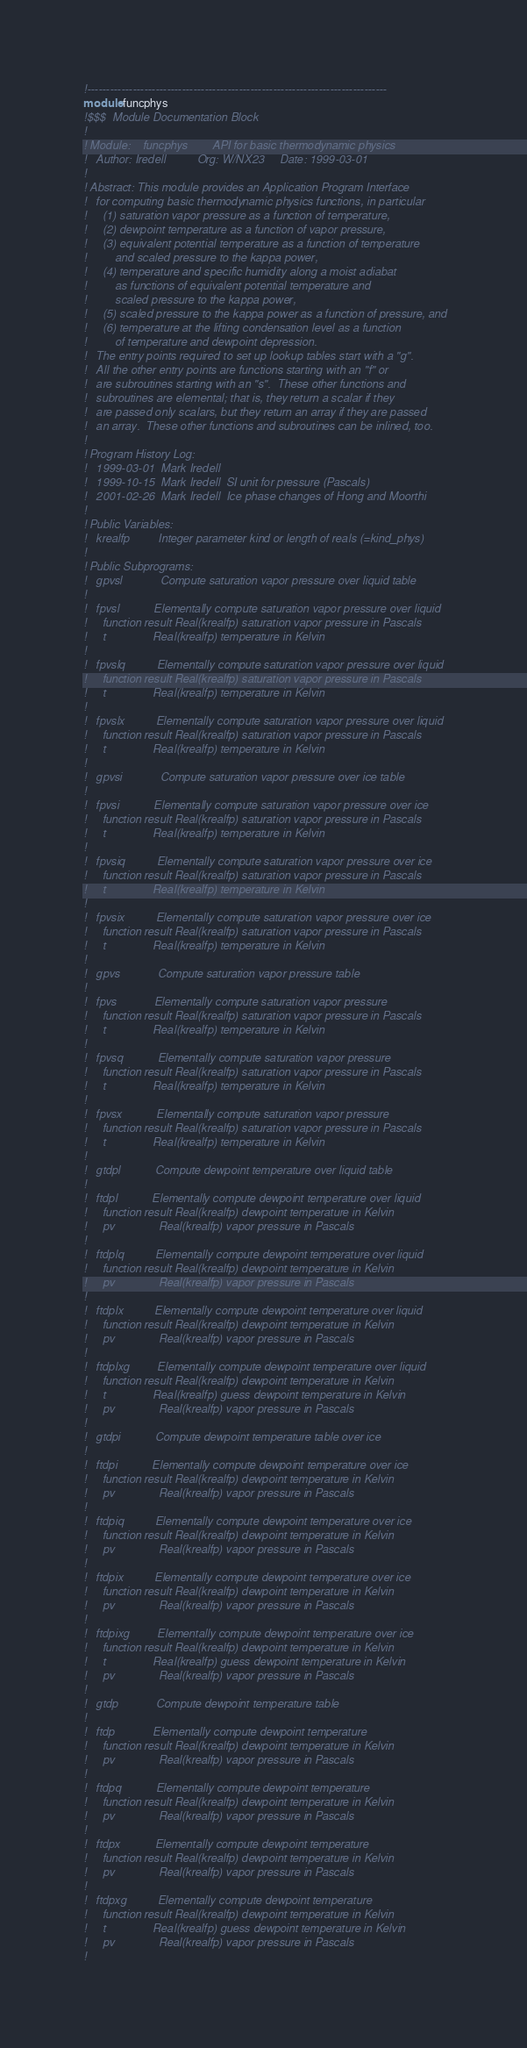Convert code to text. <code><loc_0><loc_0><loc_500><loc_500><_FORTRAN_>!-------------------------------------------------------------------------------
module funcphys
!$$$  Module Documentation Block
!
! Module:    funcphys        API for basic thermodynamic physics
!   Author: Iredell          Org: W/NX23     Date: 1999-03-01
!
! Abstract: This module provides an Application Program Interface
!   for computing basic thermodynamic physics functions, in particular
!     (1) saturation vapor pressure as a function of temperature,
!     (2) dewpoint temperature as a function of vapor pressure,
!     (3) equivalent potential temperature as a function of temperature
!         and scaled pressure to the kappa power,
!     (4) temperature and specific humidity along a moist adiabat
!         as functions of equivalent potential temperature and
!         scaled pressure to the kappa power,
!     (5) scaled pressure to the kappa power as a function of pressure, and
!     (6) temperature at the lifting condensation level as a function
!         of temperature and dewpoint depression.
!   The entry points required to set up lookup tables start with a "g".
!   All the other entry points are functions starting with an "f" or
!   are subroutines starting with an "s".  These other functions and
!   subroutines are elemental; that is, they return a scalar if they
!   are passed only scalars, but they return an array if they are passed
!   an array.  These other functions and subroutines can be inlined, too.
!
! Program History Log:
!   1999-03-01  Mark Iredell
!   1999-10-15  Mark Iredell  SI unit for pressure (Pascals)
!   2001-02-26  Mark Iredell  Ice phase changes of Hong and Moorthi
!
! Public Variables:
!   krealfp         Integer parameter kind or length of reals (=kind_phys)
!
! Public Subprograms:
!   gpvsl            Compute saturation vapor pressure over liquid table
!
!   fpvsl           Elementally compute saturation vapor pressure over liquid
!     function result Real(krealfp) saturation vapor pressure in Pascals
!     t               Real(krealfp) temperature in Kelvin
!
!   fpvslq          Elementally compute saturation vapor pressure over liquid
!     function result Real(krealfp) saturation vapor pressure in Pascals
!     t               Real(krealfp) temperature in Kelvin
!
!   fpvslx          Elementally compute saturation vapor pressure over liquid
!     function result Real(krealfp) saturation vapor pressure in Pascals
!     t               Real(krealfp) temperature in Kelvin
!
!   gpvsi            Compute saturation vapor pressure over ice table
!
!   fpvsi           Elementally compute saturation vapor pressure over ice
!     function result Real(krealfp) saturation vapor pressure in Pascals
!     t               Real(krealfp) temperature in Kelvin
!
!   fpvsiq          Elementally compute saturation vapor pressure over ice
!     function result Real(krealfp) saturation vapor pressure in Pascals
!     t               Real(krealfp) temperature in Kelvin
!
!   fpvsix          Elementally compute saturation vapor pressure over ice
!     function result Real(krealfp) saturation vapor pressure in Pascals
!     t               Real(krealfp) temperature in Kelvin
!
!   gpvs            Compute saturation vapor pressure table
!
!   fpvs            Elementally compute saturation vapor pressure
!     function result Real(krealfp) saturation vapor pressure in Pascals
!     t               Real(krealfp) temperature in Kelvin
!
!   fpvsq           Elementally compute saturation vapor pressure
!     function result Real(krealfp) saturation vapor pressure in Pascals
!     t               Real(krealfp) temperature in Kelvin
!
!   fpvsx           Elementally compute saturation vapor pressure
!     function result Real(krealfp) saturation vapor pressure in Pascals
!     t               Real(krealfp) temperature in Kelvin
!
!   gtdpl           Compute dewpoint temperature over liquid table
!
!   ftdpl           Elementally compute dewpoint temperature over liquid
!     function result Real(krealfp) dewpoint temperature in Kelvin
!     pv              Real(krealfp) vapor pressure in Pascals
!
!   ftdplq          Elementally compute dewpoint temperature over liquid
!     function result Real(krealfp) dewpoint temperature in Kelvin
!     pv              Real(krealfp) vapor pressure in Pascals
!
!   ftdplx          Elementally compute dewpoint temperature over liquid
!     function result Real(krealfp) dewpoint temperature in Kelvin
!     pv              Real(krealfp) vapor pressure in Pascals
!
!   ftdplxg         Elementally compute dewpoint temperature over liquid
!     function result Real(krealfp) dewpoint temperature in Kelvin
!     t               Real(krealfp) guess dewpoint temperature in Kelvin
!     pv              Real(krealfp) vapor pressure in Pascals
!
!   gtdpi           Compute dewpoint temperature table over ice
!
!   ftdpi           Elementally compute dewpoint temperature over ice
!     function result Real(krealfp) dewpoint temperature in Kelvin
!     pv              Real(krealfp) vapor pressure in Pascals
!
!   ftdpiq          Elementally compute dewpoint temperature over ice
!     function result Real(krealfp) dewpoint temperature in Kelvin
!     pv              Real(krealfp) vapor pressure in Pascals
!
!   ftdpix          Elementally compute dewpoint temperature over ice
!     function result Real(krealfp) dewpoint temperature in Kelvin
!     pv              Real(krealfp) vapor pressure in Pascals
!
!   ftdpixg         Elementally compute dewpoint temperature over ice
!     function result Real(krealfp) dewpoint temperature in Kelvin
!     t               Real(krealfp) guess dewpoint temperature in Kelvin
!     pv              Real(krealfp) vapor pressure in Pascals
!
!   gtdp            Compute dewpoint temperature table
!
!   ftdp            Elementally compute dewpoint temperature
!     function result Real(krealfp) dewpoint temperature in Kelvin
!     pv              Real(krealfp) vapor pressure in Pascals
!
!   ftdpq           Elementally compute dewpoint temperature
!     function result Real(krealfp) dewpoint temperature in Kelvin
!     pv              Real(krealfp) vapor pressure in Pascals
!
!   ftdpx           Elementally compute dewpoint temperature
!     function result Real(krealfp) dewpoint temperature in Kelvin
!     pv              Real(krealfp) vapor pressure in Pascals
!
!   ftdpxg          Elementally compute dewpoint temperature
!     function result Real(krealfp) dewpoint temperature in Kelvin
!     t               Real(krealfp) guess dewpoint temperature in Kelvin
!     pv              Real(krealfp) vapor pressure in Pascals
!</code> 